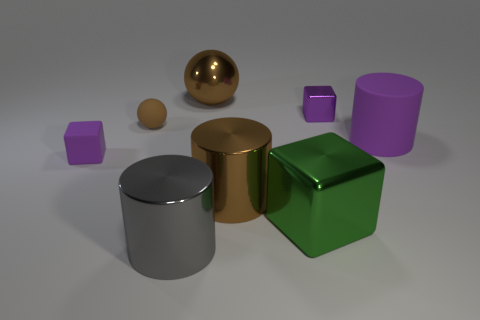Is there anything else that has the same shape as the tiny metallic object?
Make the answer very short. Yes. What shape is the small purple object right of the gray cylinder?
Keep it short and to the point. Cube. What number of large green metal objects are the same shape as the big rubber object?
Make the answer very short. 0. Is the color of the matte thing that is to the right of the green metallic block the same as the small cube to the right of the gray object?
Ensure brevity in your answer.  Yes. How many things are rubber cylinders or tiny gray shiny things?
Give a very brief answer. 1. What number of yellow cylinders have the same material as the large purple cylinder?
Give a very brief answer. 0. Are there fewer green metal objects than small purple objects?
Make the answer very short. Yes. Do the tiny sphere to the left of the brown shiny sphere and the gray object have the same material?
Make the answer very short. No. What number of spheres are either gray metallic things or large purple matte things?
Your response must be concise. 0. There is a thing that is both on the right side of the large green metal thing and left of the large purple cylinder; what shape is it?
Offer a very short reply. Cube. 